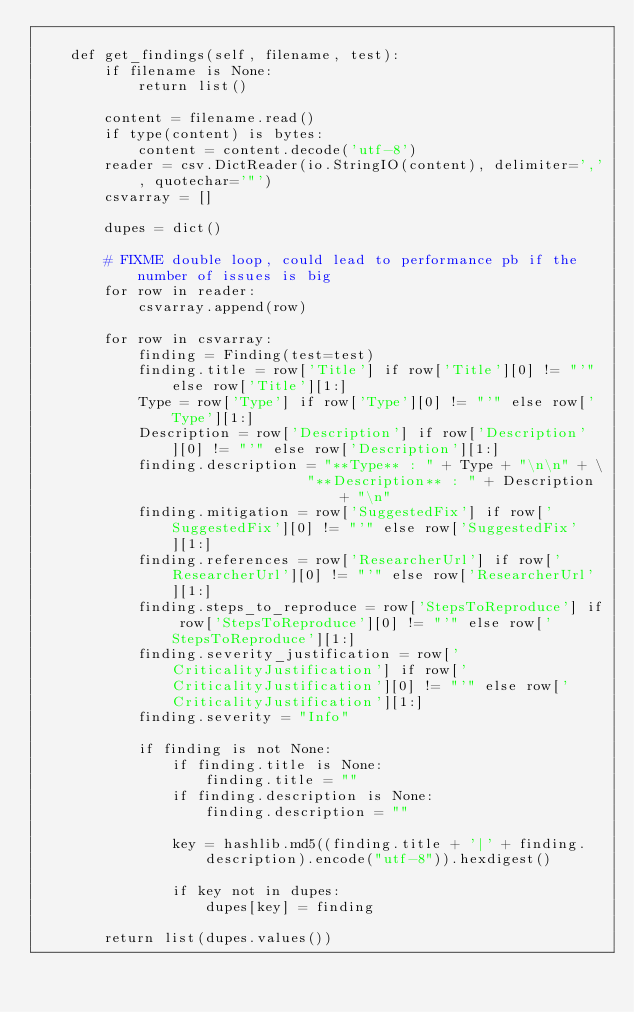<code> <loc_0><loc_0><loc_500><loc_500><_Python_>
    def get_findings(self, filename, test):
        if filename is None:
            return list()

        content = filename.read()
        if type(content) is bytes:
            content = content.decode('utf-8')
        reader = csv.DictReader(io.StringIO(content), delimiter=',', quotechar='"')
        csvarray = []

        dupes = dict()

        # FIXME double loop, could lead to performance pb if the number of issues is big
        for row in reader:
            csvarray.append(row)

        for row in csvarray:
            finding = Finding(test=test)
            finding.title = row['Title'] if row['Title'][0] != "'" else row['Title'][1:]
            Type = row['Type'] if row['Type'][0] != "'" else row['Type'][1:]
            Description = row['Description'] if row['Description'][0] != "'" else row['Description'][1:]
            finding.description = "**Type** : " + Type + "\n\n" + \
                                "**Description** : " + Description + "\n"
            finding.mitigation = row['SuggestedFix'] if row['SuggestedFix'][0] != "'" else row['SuggestedFix'][1:]
            finding.references = row['ResearcherUrl'] if row['ResearcherUrl'][0] != "'" else row['ResearcherUrl'][1:]
            finding.steps_to_reproduce = row['StepsToReproduce'] if row['StepsToReproduce'][0] != "'" else row['StepsToReproduce'][1:]
            finding.severity_justification = row['CriticalityJustification'] if row['CriticalityJustification'][0] != "'" else row['CriticalityJustification'][1:]
            finding.severity = "Info"

            if finding is not None:
                if finding.title is None:
                    finding.title = ""
                if finding.description is None:
                    finding.description = ""

                key = hashlib.md5((finding.title + '|' + finding.description).encode("utf-8")).hexdigest()

                if key not in dupes:
                    dupes[key] = finding

        return list(dupes.values())
</code> 